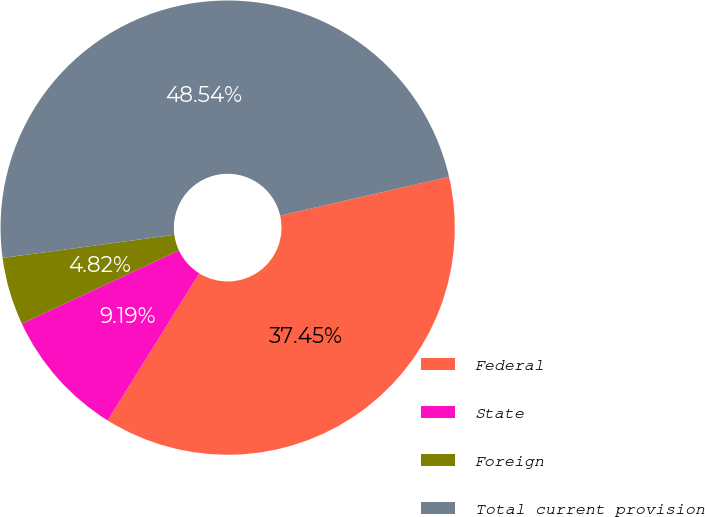Convert chart to OTSL. <chart><loc_0><loc_0><loc_500><loc_500><pie_chart><fcel>Federal<fcel>State<fcel>Foreign<fcel>Total current provision<nl><fcel>37.45%<fcel>9.19%<fcel>4.82%<fcel>48.54%<nl></chart> 